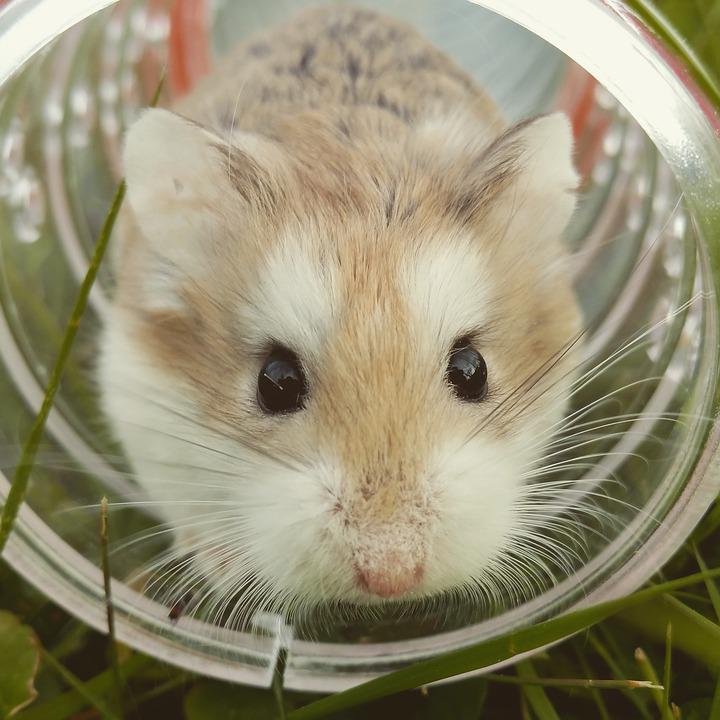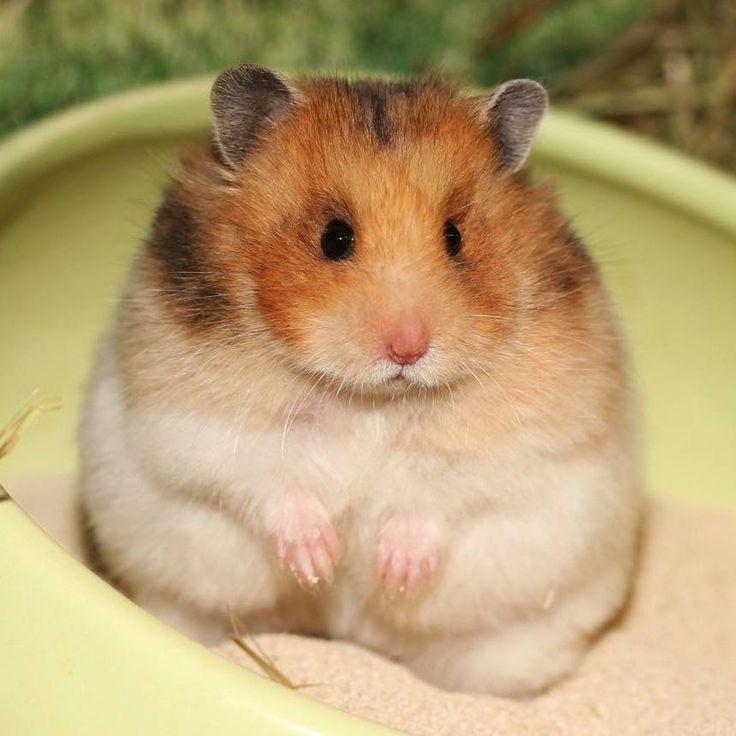The first image is the image on the left, the second image is the image on the right. Considering the images on both sides, is "The hamster on the stands facing forward with hands visible in front of its body." valid? Answer yes or no. Yes. 